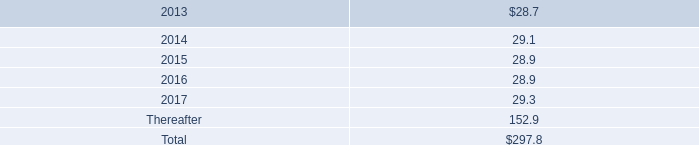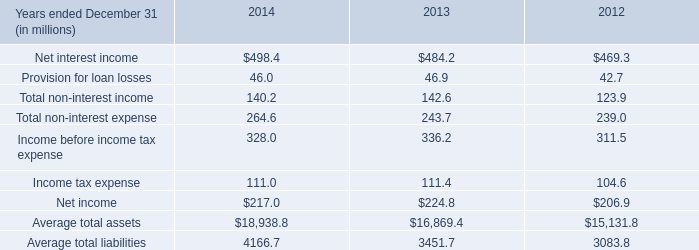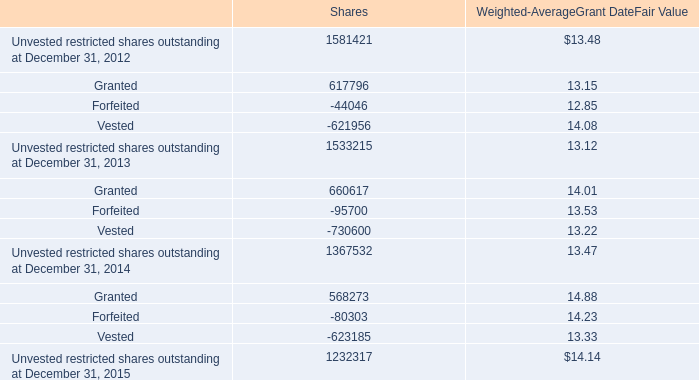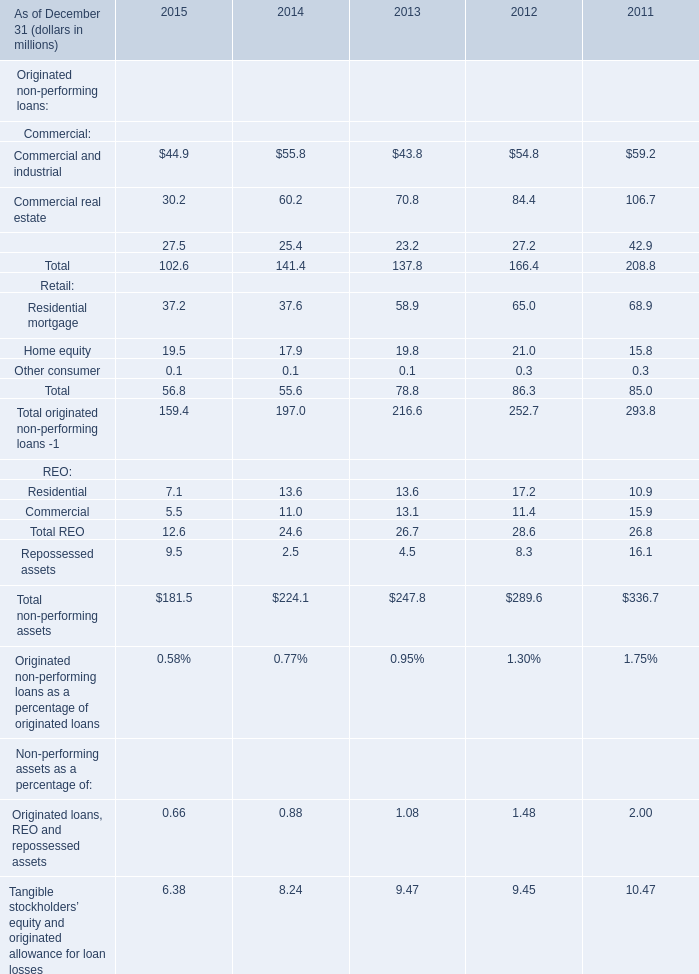what is the percentage increase in obligation for the mrrp from 2011 to 2012? 
Computations: ((22.7 - 21.6) / 21.6)
Answer: 0.05093. 